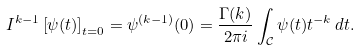Convert formula to latex. <formula><loc_0><loc_0><loc_500><loc_500>I ^ { k - 1 } \left [ \psi ( t ) \right ] _ { t = 0 } = \psi ^ { ( k - 1 ) } ( 0 ) = \frac { \Gamma ( k ) } { 2 \pi i } \int _ { \mathcal { C } } \psi ( t ) t ^ { - k } \, d t .</formula> 